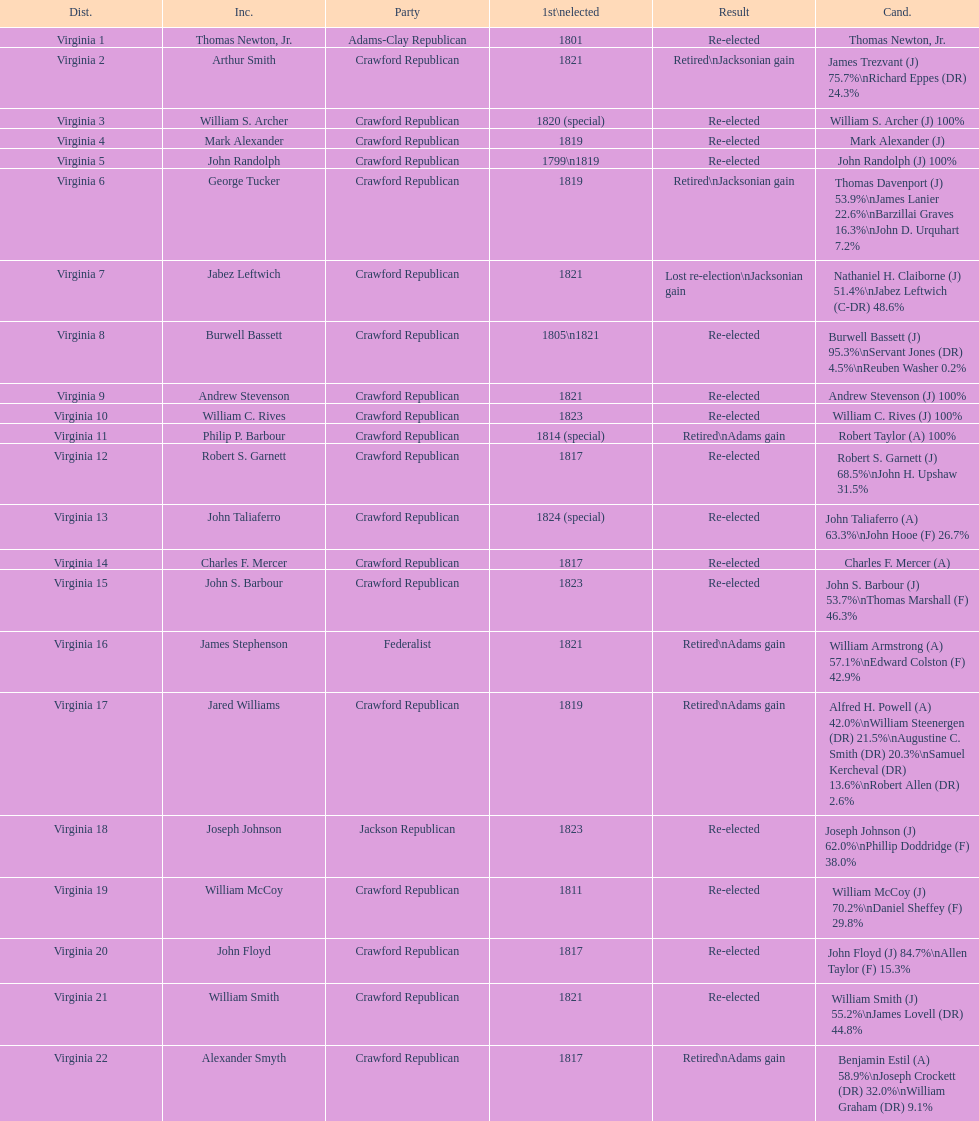Which jacksonian candidates got at least 76% of the vote in their races? Arthur Smith. 